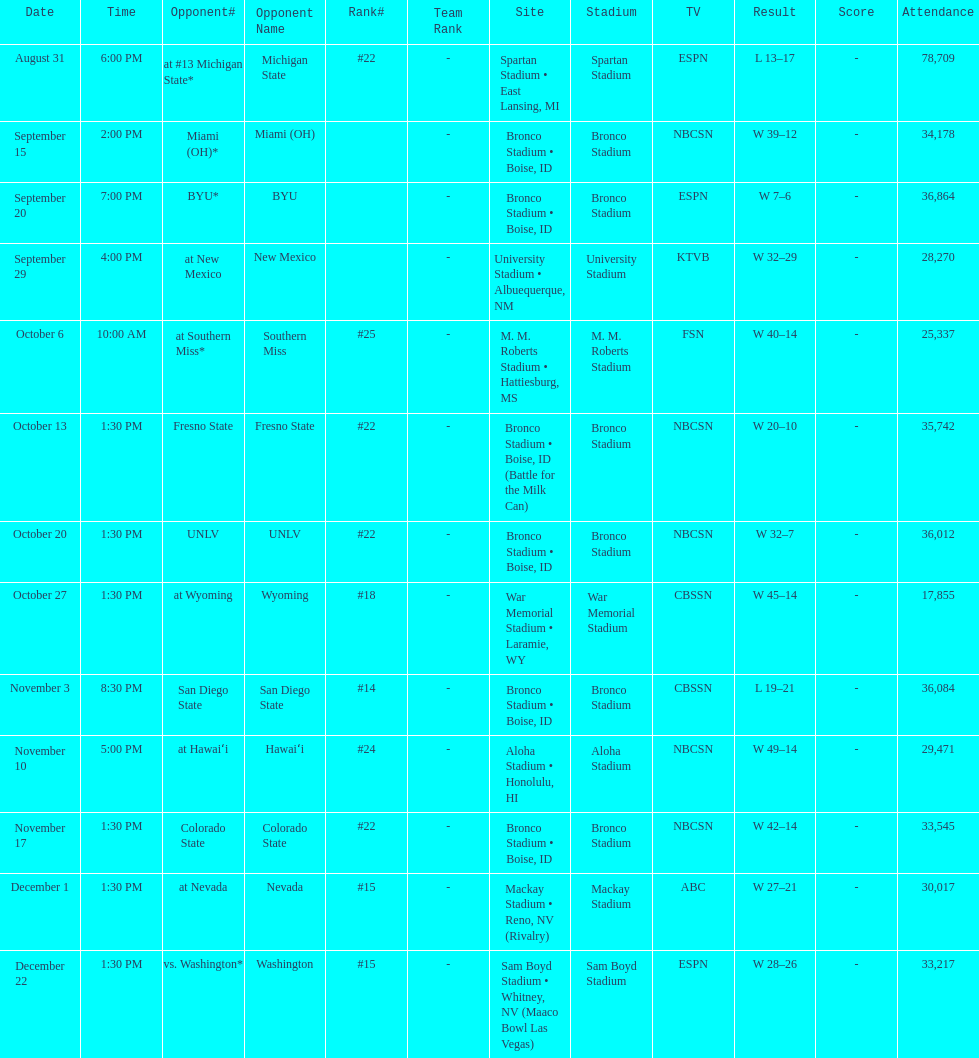Number of points scored by miami (oh) against the broncos. 12. 